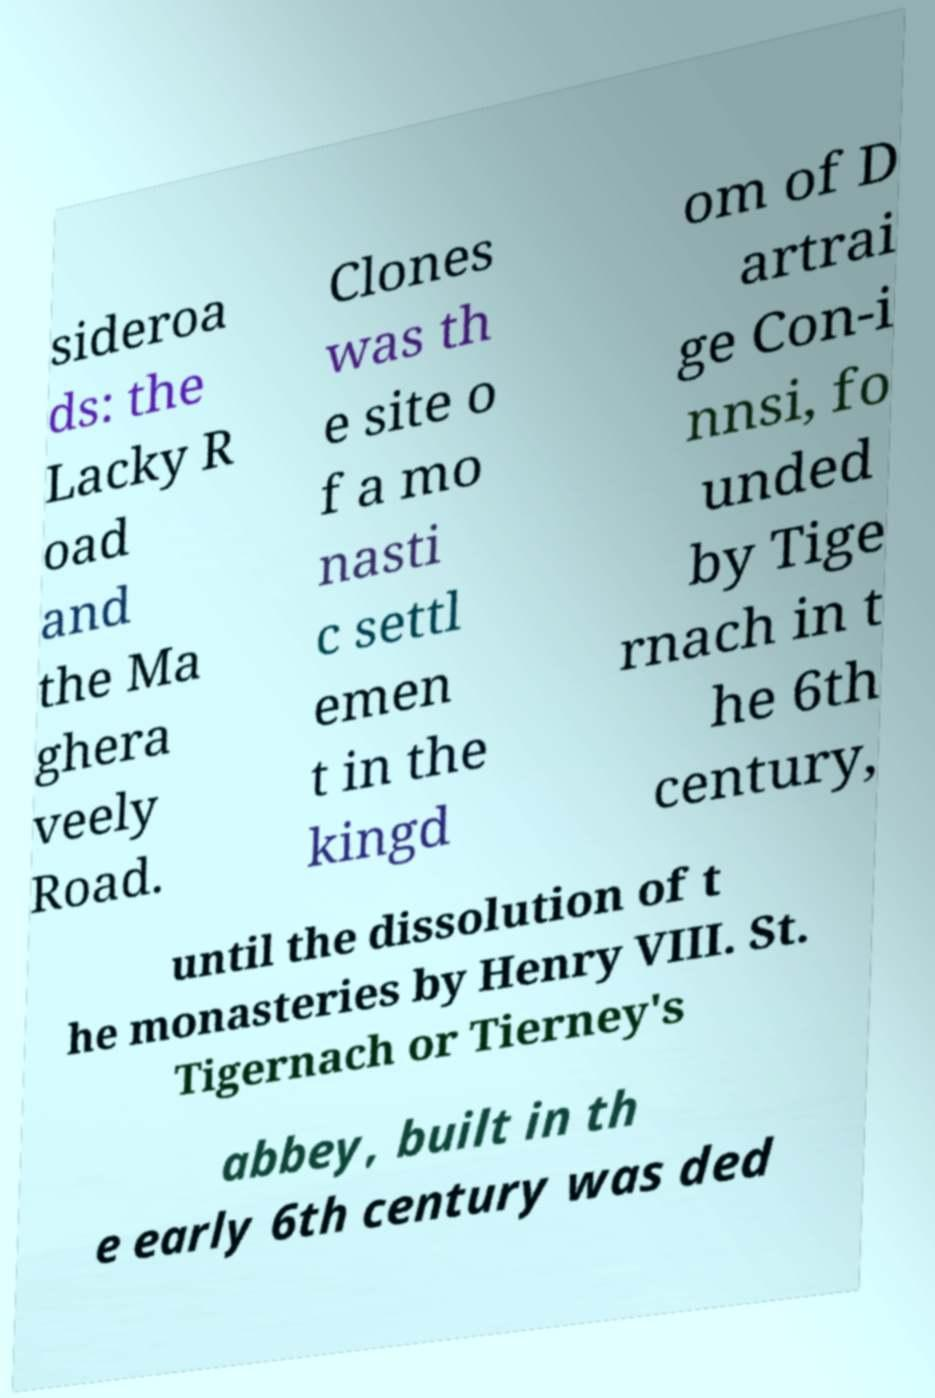I need the written content from this picture converted into text. Can you do that? sideroa ds: the Lacky R oad and the Ma ghera veely Road. Clones was th e site o f a mo nasti c settl emen t in the kingd om of D artrai ge Con-i nnsi, fo unded by Tige rnach in t he 6th century, until the dissolution of t he monasteries by Henry VIII. St. Tigernach or Tierney's abbey, built in th e early 6th century was ded 